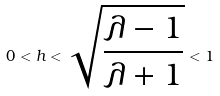Convert formula to latex. <formula><loc_0><loc_0><loc_500><loc_500>0 < h < \sqrt { \frac { \lambda - 1 } { \lambda + 1 } } < 1</formula> 